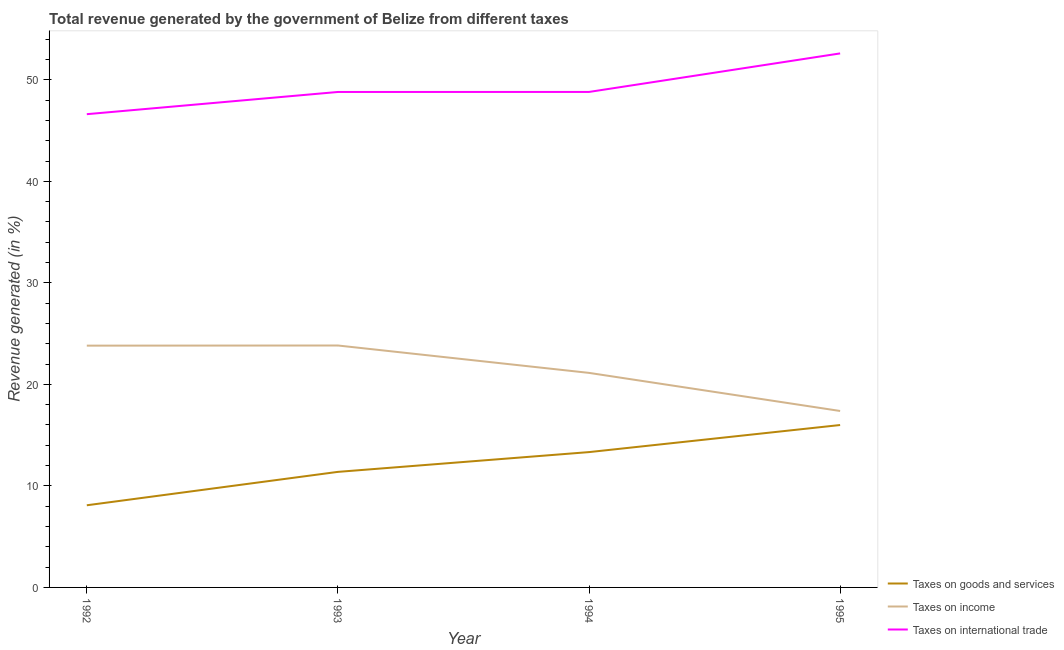What is the percentage of revenue generated by tax on international trade in 1995?
Give a very brief answer. 52.6. Across all years, what is the maximum percentage of revenue generated by taxes on income?
Provide a succinct answer. 23.83. Across all years, what is the minimum percentage of revenue generated by taxes on goods and services?
Give a very brief answer. 8.09. In which year was the percentage of revenue generated by tax on international trade maximum?
Keep it short and to the point. 1995. In which year was the percentage of revenue generated by taxes on goods and services minimum?
Give a very brief answer. 1992. What is the total percentage of revenue generated by taxes on income in the graph?
Give a very brief answer. 86.16. What is the difference between the percentage of revenue generated by taxes on income in 1993 and that in 1995?
Keep it short and to the point. 6.45. What is the difference between the percentage of revenue generated by taxes on goods and services in 1994 and the percentage of revenue generated by tax on international trade in 1992?
Your response must be concise. -33.29. What is the average percentage of revenue generated by taxes on income per year?
Ensure brevity in your answer.  21.54. In the year 1992, what is the difference between the percentage of revenue generated by taxes on goods and services and percentage of revenue generated by taxes on income?
Make the answer very short. -15.72. What is the ratio of the percentage of revenue generated by taxes on income in 1992 to that in 1994?
Provide a short and direct response. 1.13. Is the difference between the percentage of revenue generated by taxes on goods and services in 1993 and 1995 greater than the difference between the percentage of revenue generated by tax on international trade in 1993 and 1995?
Keep it short and to the point. No. What is the difference between the highest and the second highest percentage of revenue generated by taxes on income?
Your answer should be compact. 0.01. What is the difference between the highest and the lowest percentage of revenue generated by taxes on goods and services?
Your answer should be compact. 7.9. In how many years, is the percentage of revenue generated by taxes on income greater than the average percentage of revenue generated by taxes on income taken over all years?
Give a very brief answer. 2. Is it the case that in every year, the sum of the percentage of revenue generated by taxes on goods and services and percentage of revenue generated by taxes on income is greater than the percentage of revenue generated by tax on international trade?
Your answer should be compact. No. Does the percentage of revenue generated by taxes on income monotonically increase over the years?
Provide a short and direct response. No. Is the percentage of revenue generated by taxes on income strictly greater than the percentage of revenue generated by taxes on goods and services over the years?
Make the answer very short. Yes. Is the percentage of revenue generated by taxes on goods and services strictly less than the percentage of revenue generated by taxes on income over the years?
Ensure brevity in your answer.  Yes. How many years are there in the graph?
Give a very brief answer. 4. What is the difference between two consecutive major ticks on the Y-axis?
Your response must be concise. 10. Does the graph contain grids?
Offer a very short reply. No. Where does the legend appear in the graph?
Keep it short and to the point. Bottom right. What is the title of the graph?
Provide a short and direct response. Total revenue generated by the government of Belize from different taxes. Does "Negligence towards kids" appear as one of the legend labels in the graph?
Offer a terse response. No. What is the label or title of the Y-axis?
Your answer should be compact. Revenue generated (in %). What is the Revenue generated (in %) of Taxes on goods and services in 1992?
Make the answer very short. 8.09. What is the Revenue generated (in %) in Taxes on income in 1992?
Make the answer very short. 23.82. What is the Revenue generated (in %) of Taxes on international trade in 1992?
Keep it short and to the point. 46.62. What is the Revenue generated (in %) of Taxes on goods and services in 1993?
Ensure brevity in your answer.  11.38. What is the Revenue generated (in %) in Taxes on income in 1993?
Keep it short and to the point. 23.83. What is the Revenue generated (in %) in Taxes on international trade in 1993?
Your answer should be very brief. 48.8. What is the Revenue generated (in %) in Taxes on goods and services in 1994?
Make the answer very short. 13.33. What is the Revenue generated (in %) in Taxes on income in 1994?
Your answer should be very brief. 21.13. What is the Revenue generated (in %) of Taxes on international trade in 1994?
Your answer should be compact. 48.81. What is the Revenue generated (in %) of Taxes on goods and services in 1995?
Provide a short and direct response. 16. What is the Revenue generated (in %) in Taxes on income in 1995?
Provide a short and direct response. 17.38. What is the Revenue generated (in %) of Taxes on international trade in 1995?
Make the answer very short. 52.6. Across all years, what is the maximum Revenue generated (in %) of Taxes on goods and services?
Make the answer very short. 16. Across all years, what is the maximum Revenue generated (in %) in Taxes on income?
Keep it short and to the point. 23.83. Across all years, what is the maximum Revenue generated (in %) in Taxes on international trade?
Offer a very short reply. 52.6. Across all years, what is the minimum Revenue generated (in %) in Taxes on goods and services?
Offer a terse response. 8.09. Across all years, what is the minimum Revenue generated (in %) in Taxes on income?
Ensure brevity in your answer.  17.38. Across all years, what is the minimum Revenue generated (in %) of Taxes on international trade?
Your answer should be very brief. 46.62. What is the total Revenue generated (in %) in Taxes on goods and services in the graph?
Give a very brief answer. 48.8. What is the total Revenue generated (in %) of Taxes on income in the graph?
Offer a terse response. 86.16. What is the total Revenue generated (in %) of Taxes on international trade in the graph?
Your answer should be compact. 196.83. What is the difference between the Revenue generated (in %) in Taxes on goods and services in 1992 and that in 1993?
Ensure brevity in your answer.  -3.29. What is the difference between the Revenue generated (in %) in Taxes on income in 1992 and that in 1993?
Give a very brief answer. -0.01. What is the difference between the Revenue generated (in %) in Taxes on international trade in 1992 and that in 1993?
Your response must be concise. -2.19. What is the difference between the Revenue generated (in %) in Taxes on goods and services in 1992 and that in 1994?
Keep it short and to the point. -5.24. What is the difference between the Revenue generated (in %) in Taxes on income in 1992 and that in 1994?
Provide a short and direct response. 2.68. What is the difference between the Revenue generated (in %) in Taxes on international trade in 1992 and that in 1994?
Provide a succinct answer. -2.19. What is the difference between the Revenue generated (in %) in Taxes on goods and services in 1992 and that in 1995?
Make the answer very short. -7.9. What is the difference between the Revenue generated (in %) of Taxes on income in 1992 and that in 1995?
Provide a succinct answer. 6.44. What is the difference between the Revenue generated (in %) of Taxes on international trade in 1992 and that in 1995?
Give a very brief answer. -5.99. What is the difference between the Revenue generated (in %) of Taxes on goods and services in 1993 and that in 1994?
Make the answer very short. -1.95. What is the difference between the Revenue generated (in %) of Taxes on income in 1993 and that in 1994?
Keep it short and to the point. 2.7. What is the difference between the Revenue generated (in %) in Taxes on international trade in 1993 and that in 1994?
Make the answer very short. -0. What is the difference between the Revenue generated (in %) in Taxes on goods and services in 1993 and that in 1995?
Provide a succinct answer. -4.61. What is the difference between the Revenue generated (in %) of Taxes on income in 1993 and that in 1995?
Your answer should be compact. 6.45. What is the difference between the Revenue generated (in %) in Taxes on international trade in 1993 and that in 1995?
Make the answer very short. -3.8. What is the difference between the Revenue generated (in %) in Taxes on goods and services in 1994 and that in 1995?
Make the answer very short. -2.67. What is the difference between the Revenue generated (in %) of Taxes on income in 1994 and that in 1995?
Offer a very short reply. 3.75. What is the difference between the Revenue generated (in %) in Taxes on international trade in 1994 and that in 1995?
Ensure brevity in your answer.  -3.79. What is the difference between the Revenue generated (in %) in Taxes on goods and services in 1992 and the Revenue generated (in %) in Taxes on income in 1993?
Your answer should be very brief. -15.74. What is the difference between the Revenue generated (in %) in Taxes on goods and services in 1992 and the Revenue generated (in %) in Taxes on international trade in 1993?
Offer a terse response. -40.71. What is the difference between the Revenue generated (in %) of Taxes on income in 1992 and the Revenue generated (in %) of Taxes on international trade in 1993?
Keep it short and to the point. -24.99. What is the difference between the Revenue generated (in %) of Taxes on goods and services in 1992 and the Revenue generated (in %) of Taxes on income in 1994?
Provide a succinct answer. -13.04. What is the difference between the Revenue generated (in %) in Taxes on goods and services in 1992 and the Revenue generated (in %) in Taxes on international trade in 1994?
Keep it short and to the point. -40.72. What is the difference between the Revenue generated (in %) of Taxes on income in 1992 and the Revenue generated (in %) of Taxes on international trade in 1994?
Offer a very short reply. -24.99. What is the difference between the Revenue generated (in %) in Taxes on goods and services in 1992 and the Revenue generated (in %) in Taxes on income in 1995?
Your answer should be compact. -9.29. What is the difference between the Revenue generated (in %) of Taxes on goods and services in 1992 and the Revenue generated (in %) of Taxes on international trade in 1995?
Make the answer very short. -44.51. What is the difference between the Revenue generated (in %) of Taxes on income in 1992 and the Revenue generated (in %) of Taxes on international trade in 1995?
Give a very brief answer. -28.79. What is the difference between the Revenue generated (in %) of Taxes on goods and services in 1993 and the Revenue generated (in %) of Taxes on income in 1994?
Your answer should be compact. -9.75. What is the difference between the Revenue generated (in %) of Taxes on goods and services in 1993 and the Revenue generated (in %) of Taxes on international trade in 1994?
Your response must be concise. -37.43. What is the difference between the Revenue generated (in %) of Taxes on income in 1993 and the Revenue generated (in %) of Taxes on international trade in 1994?
Your answer should be very brief. -24.98. What is the difference between the Revenue generated (in %) in Taxes on goods and services in 1993 and the Revenue generated (in %) in Taxes on income in 1995?
Keep it short and to the point. -6. What is the difference between the Revenue generated (in %) in Taxes on goods and services in 1993 and the Revenue generated (in %) in Taxes on international trade in 1995?
Provide a succinct answer. -41.22. What is the difference between the Revenue generated (in %) of Taxes on income in 1993 and the Revenue generated (in %) of Taxes on international trade in 1995?
Offer a very short reply. -28.77. What is the difference between the Revenue generated (in %) in Taxes on goods and services in 1994 and the Revenue generated (in %) in Taxes on income in 1995?
Make the answer very short. -4.05. What is the difference between the Revenue generated (in %) in Taxes on goods and services in 1994 and the Revenue generated (in %) in Taxes on international trade in 1995?
Offer a terse response. -39.27. What is the difference between the Revenue generated (in %) in Taxes on income in 1994 and the Revenue generated (in %) in Taxes on international trade in 1995?
Your response must be concise. -31.47. What is the average Revenue generated (in %) in Taxes on goods and services per year?
Provide a short and direct response. 12.2. What is the average Revenue generated (in %) of Taxes on income per year?
Ensure brevity in your answer.  21.54. What is the average Revenue generated (in %) in Taxes on international trade per year?
Provide a succinct answer. 49.21. In the year 1992, what is the difference between the Revenue generated (in %) of Taxes on goods and services and Revenue generated (in %) of Taxes on income?
Keep it short and to the point. -15.72. In the year 1992, what is the difference between the Revenue generated (in %) in Taxes on goods and services and Revenue generated (in %) in Taxes on international trade?
Make the answer very short. -38.53. In the year 1992, what is the difference between the Revenue generated (in %) in Taxes on income and Revenue generated (in %) in Taxes on international trade?
Keep it short and to the point. -22.8. In the year 1993, what is the difference between the Revenue generated (in %) of Taxes on goods and services and Revenue generated (in %) of Taxes on income?
Your answer should be compact. -12.45. In the year 1993, what is the difference between the Revenue generated (in %) of Taxes on goods and services and Revenue generated (in %) of Taxes on international trade?
Offer a terse response. -37.42. In the year 1993, what is the difference between the Revenue generated (in %) of Taxes on income and Revenue generated (in %) of Taxes on international trade?
Offer a very short reply. -24.97. In the year 1994, what is the difference between the Revenue generated (in %) of Taxes on goods and services and Revenue generated (in %) of Taxes on income?
Make the answer very short. -7.8. In the year 1994, what is the difference between the Revenue generated (in %) of Taxes on goods and services and Revenue generated (in %) of Taxes on international trade?
Keep it short and to the point. -35.48. In the year 1994, what is the difference between the Revenue generated (in %) of Taxes on income and Revenue generated (in %) of Taxes on international trade?
Offer a terse response. -27.67. In the year 1995, what is the difference between the Revenue generated (in %) in Taxes on goods and services and Revenue generated (in %) in Taxes on income?
Your response must be concise. -1.38. In the year 1995, what is the difference between the Revenue generated (in %) in Taxes on goods and services and Revenue generated (in %) in Taxes on international trade?
Provide a short and direct response. -36.61. In the year 1995, what is the difference between the Revenue generated (in %) of Taxes on income and Revenue generated (in %) of Taxes on international trade?
Your response must be concise. -35.22. What is the ratio of the Revenue generated (in %) in Taxes on goods and services in 1992 to that in 1993?
Your response must be concise. 0.71. What is the ratio of the Revenue generated (in %) of Taxes on international trade in 1992 to that in 1993?
Make the answer very short. 0.96. What is the ratio of the Revenue generated (in %) in Taxes on goods and services in 1992 to that in 1994?
Your answer should be very brief. 0.61. What is the ratio of the Revenue generated (in %) in Taxes on income in 1992 to that in 1994?
Your response must be concise. 1.13. What is the ratio of the Revenue generated (in %) in Taxes on international trade in 1992 to that in 1994?
Your answer should be compact. 0.96. What is the ratio of the Revenue generated (in %) in Taxes on goods and services in 1992 to that in 1995?
Offer a terse response. 0.51. What is the ratio of the Revenue generated (in %) of Taxes on income in 1992 to that in 1995?
Keep it short and to the point. 1.37. What is the ratio of the Revenue generated (in %) of Taxes on international trade in 1992 to that in 1995?
Offer a terse response. 0.89. What is the ratio of the Revenue generated (in %) of Taxes on goods and services in 1993 to that in 1994?
Make the answer very short. 0.85. What is the ratio of the Revenue generated (in %) of Taxes on income in 1993 to that in 1994?
Offer a terse response. 1.13. What is the ratio of the Revenue generated (in %) of Taxes on goods and services in 1993 to that in 1995?
Your answer should be compact. 0.71. What is the ratio of the Revenue generated (in %) in Taxes on income in 1993 to that in 1995?
Ensure brevity in your answer.  1.37. What is the ratio of the Revenue generated (in %) of Taxes on international trade in 1993 to that in 1995?
Your response must be concise. 0.93. What is the ratio of the Revenue generated (in %) of Taxes on income in 1994 to that in 1995?
Provide a short and direct response. 1.22. What is the ratio of the Revenue generated (in %) of Taxes on international trade in 1994 to that in 1995?
Provide a short and direct response. 0.93. What is the difference between the highest and the second highest Revenue generated (in %) in Taxes on goods and services?
Offer a very short reply. 2.67. What is the difference between the highest and the second highest Revenue generated (in %) of Taxes on income?
Your answer should be compact. 0.01. What is the difference between the highest and the second highest Revenue generated (in %) of Taxes on international trade?
Give a very brief answer. 3.79. What is the difference between the highest and the lowest Revenue generated (in %) of Taxes on goods and services?
Offer a very short reply. 7.9. What is the difference between the highest and the lowest Revenue generated (in %) in Taxes on income?
Ensure brevity in your answer.  6.45. What is the difference between the highest and the lowest Revenue generated (in %) in Taxes on international trade?
Ensure brevity in your answer.  5.99. 